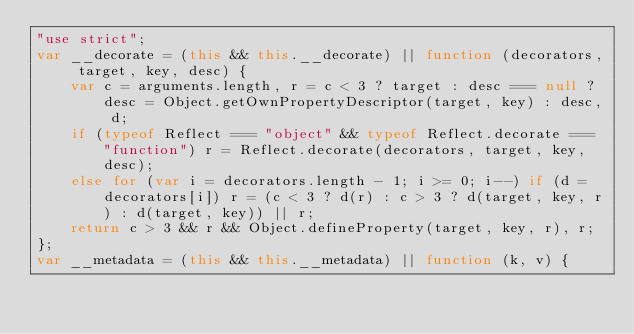Convert code to text. <code><loc_0><loc_0><loc_500><loc_500><_JavaScript_>"use strict";
var __decorate = (this && this.__decorate) || function (decorators, target, key, desc) {
    var c = arguments.length, r = c < 3 ? target : desc === null ? desc = Object.getOwnPropertyDescriptor(target, key) : desc, d;
    if (typeof Reflect === "object" && typeof Reflect.decorate === "function") r = Reflect.decorate(decorators, target, key, desc);
    else for (var i = decorators.length - 1; i >= 0; i--) if (d = decorators[i]) r = (c < 3 ? d(r) : c > 3 ? d(target, key, r) : d(target, key)) || r;
    return c > 3 && r && Object.defineProperty(target, key, r), r;
};
var __metadata = (this && this.__metadata) || function (k, v) {</code> 